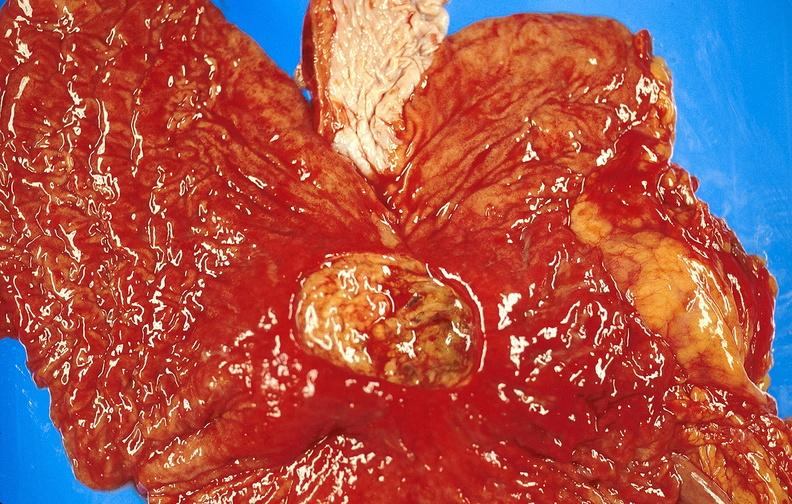s gastrointestinal present?
Answer the question using a single word or phrase. Yes 